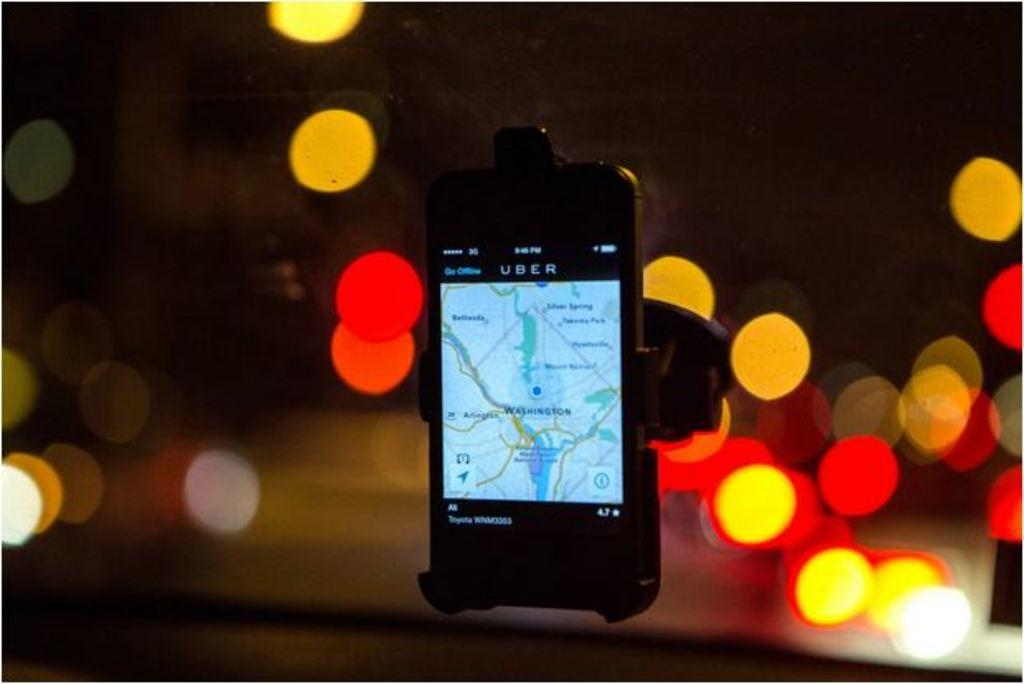<image>
Provide a brief description of the given image. A phone screen displays a map and the title Uber. 